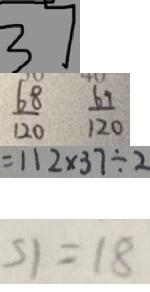Convert formula to latex. <formula><loc_0><loc_0><loc_500><loc_500>3 7 
 \frac { 6 8 } { 1 2 0 } \frac { 6 9 } { 1 2 0 } 
 = 1 1 2 \times 3 7 \div 2 
 S 1 = 1 8</formula> 